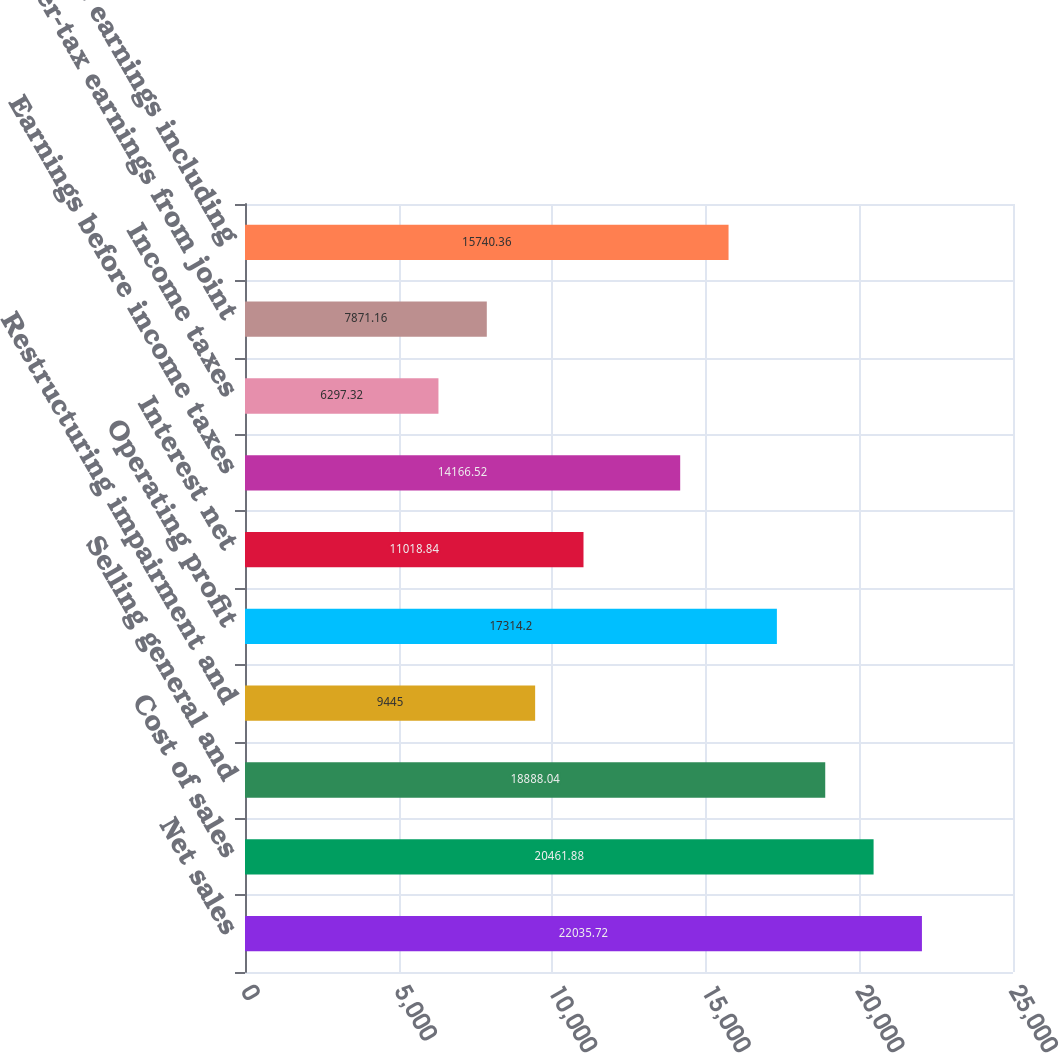<chart> <loc_0><loc_0><loc_500><loc_500><bar_chart><fcel>Net sales<fcel>Cost of sales<fcel>Selling general and<fcel>Restructuring impairment and<fcel>Operating profit<fcel>Interest net<fcel>Earnings before income taxes<fcel>Income taxes<fcel>After-tax earnings from joint<fcel>Net earnings including<nl><fcel>22035.7<fcel>20461.9<fcel>18888<fcel>9445<fcel>17314.2<fcel>11018.8<fcel>14166.5<fcel>6297.32<fcel>7871.16<fcel>15740.4<nl></chart> 